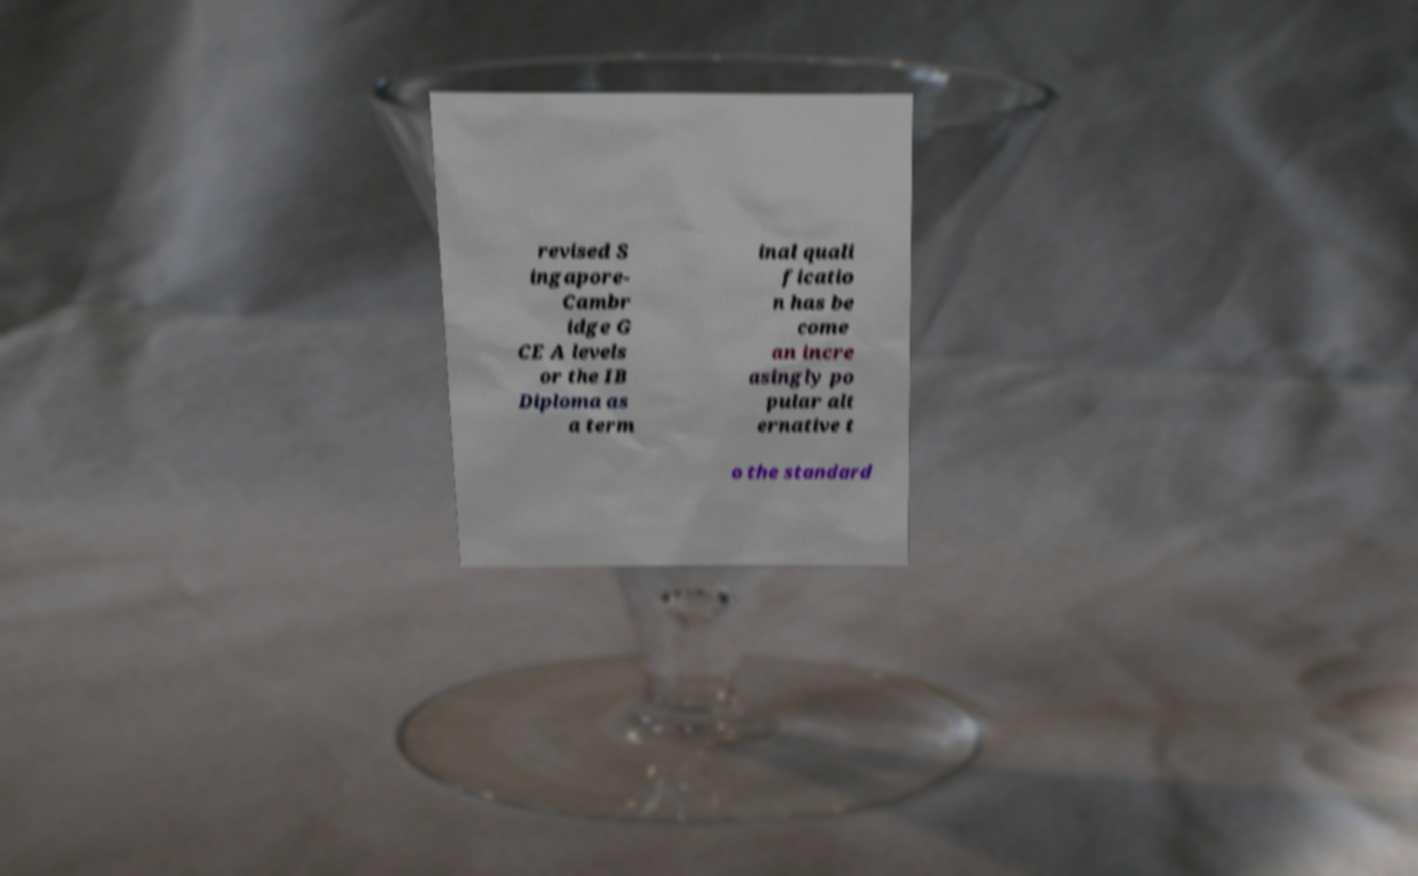Could you extract and type out the text from this image? revised S ingapore- Cambr idge G CE A levels or the IB Diploma as a term inal quali ficatio n has be come an incre asingly po pular alt ernative t o the standard 